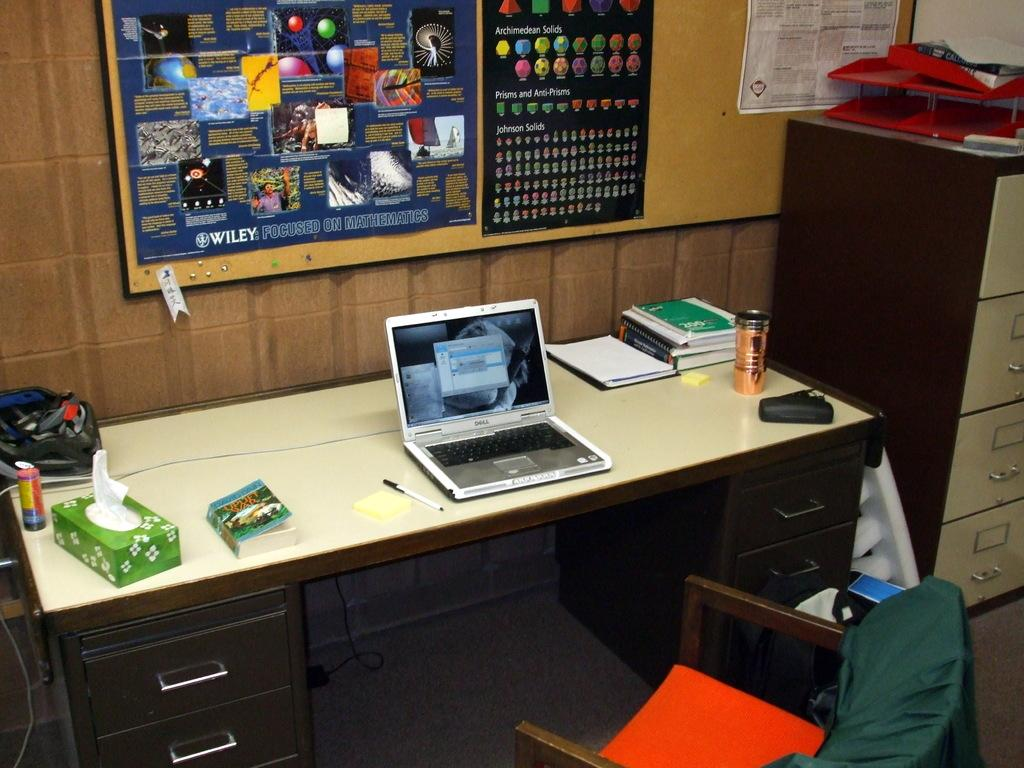Provide a one-sentence caption for the provided image. an open laptop on a desk in front of a post which has the words 'Johnson solids' on it. 